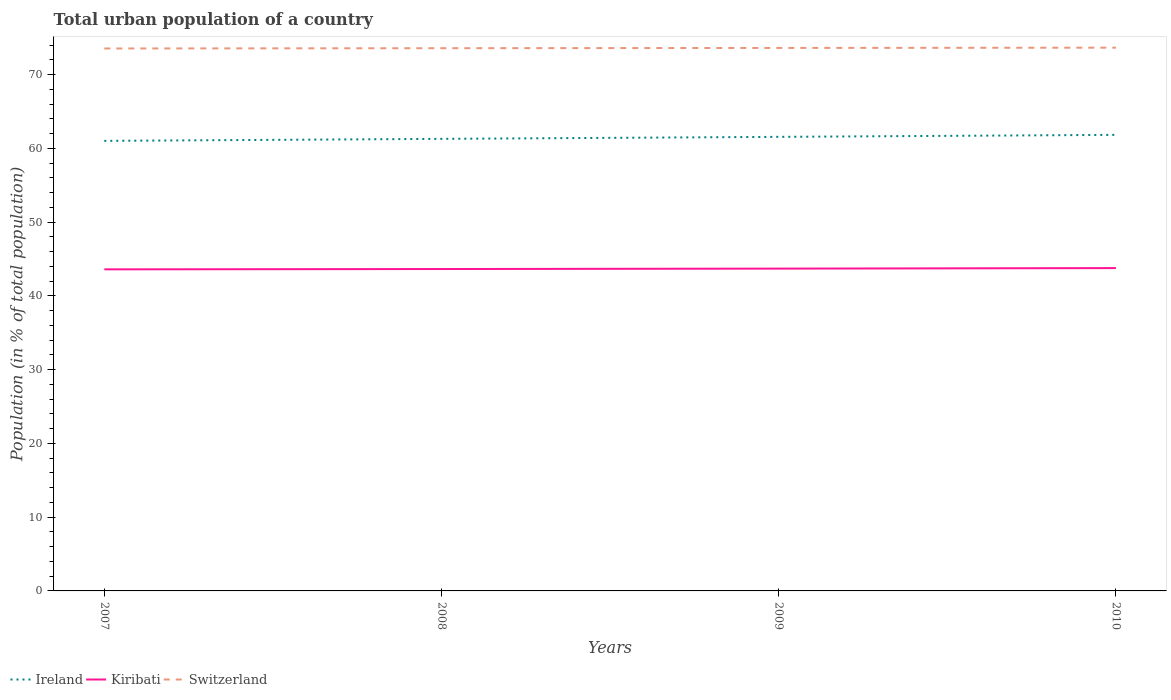Does the line corresponding to Ireland intersect with the line corresponding to Kiribati?
Your answer should be very brief. No. Across all years, what is the maximum urban population in Kiribati?
Keep it short and to the point. 43.6. What is the total urban population in Switzerland in the graph?
Give a very brief answer. -0.08. What is the difference between the highest and the second highest urban population in Switzerland?
Your answer should be very brief. 0.11. What is the difference between the highest and the lowest urban population in Ireland?
Ensure brevity in your answer.  2. How many lines are there?
Your answer should be very brief. 3. Are the values on the major ticks of Y-axis written in scientific E-notation?
Your answer should be compact. No. Does the graph contain grids?
Keep it short and to the point. No. How many legend labels are there?
Keep it short and to the point. 3. What is the title of the graph?
Ensure brevity in your answer.  Total urban population of a country. Does "Philippines" appear as one of the legend labels in the graph?
Your response must be concise. No. What is the label or title of the X-axis?
Provide a succinct answer. Years. What is the label or title of the Y-axis?
Your response must be concise. Population (in % of total population). What is the Population (in % of total population) of Ireland in 2007?
Provide a short and direct response. 61.02. What is the Population (in % of total population) in Kiribati in 2007?
Offer a terse response. 43.6. What is the Population (in % of total population) in Switzerland in 2007?
Your answer should be very brief. 73.55. What is the Population (in % of total population) of Ireland in 2008?
Keep it short and to the point. 61.3. What is the Population (in % of total population) in Kiribati in 2008?
Your answer should be very brief. 43.65. What is the Population (in % of total population) in Switzerland in 2008?
Provide a succinct answer. 73.59. What is the Population (in % of total population) in Ireland in 2009?
Your response must be concise. 61.57. What is the Population (in % of total population) of Kiribati in 2009?
Your answer should be very brief. 43.7. What is the Population (in % of total population) of Switzerland in 2009?
Keep it short and to the point. 73.62. What is the Population (in % of total population) of Ireland in 2010?
Your answer should be compact. 61.84. What is the Population (in % of total population) in Kiribati in 2010?
Your answer should be very brief. 43.77. What is the Population (in % of total population) of Switzerland in 2010?
Make the answer very short. 73.66. Across all years, what is the maximum Population (in % of total population) in Ireland?
Keep it short and to the point. 61.84. Across all years, what is the maximum Population (in % of total population) in Kiribati?
Provide a succinct answer. 43.77. Across all years, what is the maximum Population (in % of total population) in Switzerland?
Your answer should be very brief. 73.66. Across all years, what is the minimum Population (in % of total population) in Ireland?
Give a very brief answer. 61.02. Across all years, what is the minimum Population (in % of total population) in Kiribati?
Offer a very short reply. 43.6. Across all years, what is the minimum Population (in % of total population) in Switzerland?
Offer a very short reply. 73.55. What is the total Population (in % of total population) in Ireland in the graph?
Offer a very short reply. 245.73. What is the total Population (in % of total population) of Kiribati in the graph?
Your response must be concise. 174.73. What is the total Population (in % of total population) of Switzerland in the graph?
Give a very brief answer. 294.43. What is the difference between the Population (in % of total population) of Ireland in 2007 and that in 2008?
Ensure brevity in your answer.  -0.27. What is the difference between the Population (in % of total population) of Kiribati in 2007 and that in 2008?
Give a very brief answer. -0.04. What is the difference between the Population (in % of total population) of Switzerland in 2007 and that in 2008?
Offer a terse response. -0.04. What is the difference between the Population (in % of total population) of Ireland in 2007 and that in 2009?
Keep it short and to the point. -0.54. What is the difference between the Population (in % of total population) of Kiribati in 2007 and that in 2009?
Offer a very short reply. -0.1. What is the difference between the Population (in % of total population) of Switzerland in 2007 and that in 2009?
Your answer should be compact. -0.07. What is the difference between the Population (in % of total population) in Ireland in 2007 and that in 2010?
Your answer should be very brief. -0.81. What is the difference between the Population (in % of total population) of Kiribati in 2007 and that in 2010?
Make the answer very short. -0.17. What is the difference between the Population (in % of total population) in Switzerland in 2007 and that in 2010?
Your answer should be compact. -0.11. What is the difference between the Population (in % of total population) in Ireland in 2008 and that in 2009?
Your answer should be compact. -0.27. What is the difference between the Population (in % of total population) in Kiribati in 2008 and that in 2009?
Your response must be concise. -0.06. What is the difference between the Population (in % of total population) in Switzerland in 2008 and that in 2009?
Ensure brevity in your answer.  -0.04. What is the difference between the Population (in % of total population) of Ireland in 2008 and that in 2010?
Make the answer very short. -0.54. What is the difference between the Population (in % of total population) of Kiribati in 2008 and that in 2010?
Your response must be concise. -0.13. What is the difference between the Population (in % of total population) in Switzerland in 2008 and that in 2010?
Provide a short and direct response. -0.07. What is the difference between the Population (in % of total population) of Ireland in 2009 and that in 2010?
Your answer should be compact. -0.27. What is the difference between the Population (in % of total population) of Kiribati in 2009 and that in 2010?
Offer a terse response. -0.07. What is the difference between the Population (in % of total population) of Switzerland in 2009 and that in 2010?
Provide a short and direct response. -0.04. What is the difference between the Population (in % of total population) of Ireland in 2007 and the Population (in % of total population) of Kiribati in 2008?
Offer a very short reply. 17.38. What is the difference between the Population (in % of total population) of Ireland in 2007 and the Population (in % of total population) of Switzerland in 2008?
Keep it short and to the point. -12.56. What is the difference between the Population (in % of total population) of Kiribati in 2007 and the Population (in % of total population) of Switzerland in 2008?
Make the answer very short. -29.98. What is the difference between the Population (in % of total population) of Ireland in 2007 and the Population (in % of total population) of Kiribati in 2009?
Your answer should be compact. 17.32. What is the difference between the Population (in % of total population) of Ireland in 2007 and the Population (in % of total population) of Switzerland in 2009?
Your answer should be very brief. -12.6. What is the difference between the Population (in % of total population) in Kiribati in 2007 and the Population (in % of total population) in Switzerland in 2009?
Your answer should be compact. -30.02. What is the difference between the Population (in % of total population) of Ireland in 2007 and the Population (in % of total population) of Kiribati in 2010?
Your response must be concise. 17.25. What is the difference between the Population (in % of total population) in Ireland in 2007 and the Population (in % of total population) in Switzerland in 2010?
Your answer should be compact. -12.64. What is the difference between the Population (in % of total population) of Kiribati in 2007 and the Population (in % of total population) of Switzerland in 2010?
Keep it short and to the point. -30.06. What is the difference between the Population (in % of total population) of Ireland in 2008 and the Population (in % of total population) of Kiribati in 2009?
Ensure brevity in your answer.  17.59. What is the difference between the Population (in % of total population) of Ireland in 2008 and the Population (in % of total population) of Switzerland in 2009?
Make the answer very short. -12.33. What is the difference between the Population (in % of total population) of Kiribati in 2008 and the Population (in % of total population) of Switzerland in 2009?
Make the answer very short. -29.98. What is the difference between the Population (in % of total population) of Ireland in 2008 and the Population (in % of total population) of Kiribati in 2010?
Ensure brevity in your answer.  17.52. What is the difference between the Population (in % of total population) of Ireland in 2008 and the Population (in % of total population) of Switzerland in 2010?
Your answer should be compact. -12.37. What is the difference between the Population (in % of total population) of Kiribati in 2008 and the Population (in % of total population) of Switzerland in 2010?
Your response must be concise. -30.02. What is the difference between the Population (in % of total population) of Ireland in 2009 and the Population (in % of total population) of Kiribati in 2010?
Your answer should be compact. 17.8. What is the difference between the Population (in % of total population) in Ireland in 2009 and the Population (in % of total population) in Switzerland in 2010?
Provide a succinct answer. -12.09. What is the difference between the Population (in % of total population) in Kiribati in 2009 and the Population (in % of total population) in Switzerland in 2010?
Ensure brevity in your answer.  -29.96. What is the average Population (in % of total population) of Ireland per year?
Your answer should be very brief. 61.43. What is the average Population (in % of total population) in Kiribati per year?
Your answer should be compact. 43.68. What is the average Population (in % of total population) in Switzerland per year?
Offer a very short reply. 73.61. In the year 2007, what is the difference between the Population (in % of total population) in Ireland and Population (in % of total population) in Kiribati?
Your answer should be very brief. 17.42. In the year 2007, what is the difference between the Population (in % of total population) of Ireland and Population (in % of total population) of Switzerland?
Ensure brevity in your answer.  -12.53. In the year 2007, what is the difference between the Population (in % of total population) of Kiribati and Population (in % of total population) of Switzerland?
Ensure brevity in your answer.  -29.95. In the year 2008, what is the difference between the Population (in % of total population) in Ireland and Population (in % of total population) in Kiribati?
Keep it short and to the point. 17.65. In the year 2008, what is the difference between the Population (in % of total population) of Ireland and Population (in % of total population) of Switzerland?
Offer a very short reply. -12.29. In the year 2008, what is the difference between the Population (in % of total population) of Kiribati and Population (in % of total population) of Switzerland?
Make the answer very short. -29.94. In the year 2009, what is the difference between the Population (in % of total population) in Ireland and Population (in % of total population) in Kiribati?
Your answer should be compact. 17.86. In the year 2009, what is the difference between the Population (in % of total population) in Ireland and Population (in % of total population) in Switzerland?
Offer a terse response. -12.06. In the year 2009, what is the difference between the Population (in % of total population) of Kiribati and Population (in % of total population) of Switzerland?
Offer a terse response. -29.92. In the year 2010, what is the difference between the Population (in % of total population) in Ireland and Population (in % of total population) in Kiribati?
Your answer should be compact. 18.07. In the year 2010, what is the difference between the Population (in % of total population) in Ireland and Population (in % of total population) in Switzerland?
Provide a succinct answer. -11.82. In the year 2010, what is the difference between the Population (in % of total population) in Kiribati and Population (in % of total population) in Switzerland?
Make the answer very short. -29.89. What is the ratio of the Population (in % of total population) in Ireland in 2007 to that in 2008?
Make the answer very short. 1. What is the ratio of the Population (in % of total population) of Switzerland in 2007 to that in 2010?
Ensure brevity in your answer.  1. What is the ratio of the Population (in % of total population) of Ireland in 2008 to that in 2009?
Make the answer very short. 1. What is the ratio of the Population (in % of total population) of Kiribati in 2008 to that in 2009?
Give a very brief answer. 1. What is the difference between the highest and the second highest Population (in % of total population) in Ireland?
Provide a short and direct response. 0.27. What is the difference between the highest and the second highest Population (in % of total population) of Kiribati?
Offer a terse response. 0.07. What is the difference between the highest and the second highest Population (in % of total population) of Switzerland?
Provide a succinct answer. 0.04. What is the difference between the highest and the lowest Population (in % of total population) in Ireland?
Offer a terse response. 0.81. What is the difference between the highest and the lowest Population (in % of total population) of Kiribati?
Provide a short and direct response. 0.17. What is the difference between the highest and the lowest Population (in % of total population) of Switzerland?
Your response must be concise. 0.11. 